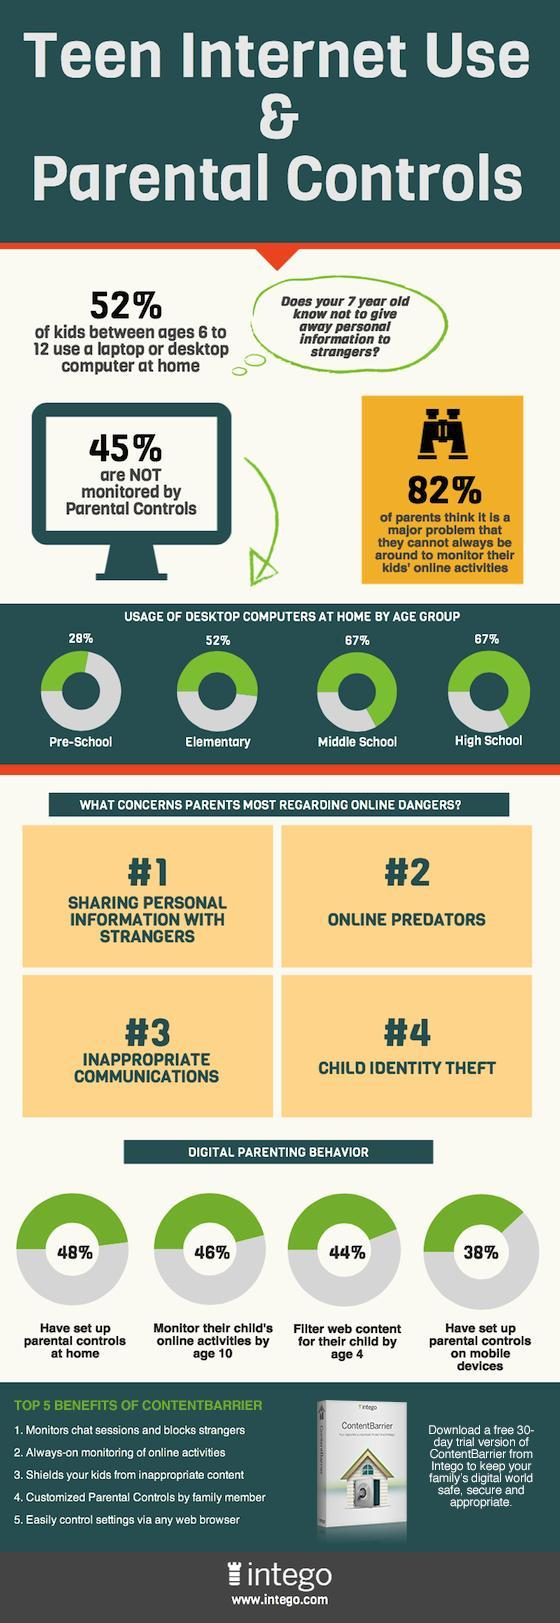What percent of high school students use desktop computers at home?
Answer the question with a short phrase. 67% What matter is of second highest concern for parents regarding children's online safety? online predators what percent of kids using computers at home are of elementary school age? 52% How  many of the parents have set up parental control on mobile devices? 38% How many of the parents have setup parental controls at home? 48% What percent of kids using computers at home are not supervised by parental controls? 45% What percent of pre-school kids use computers at home? 28% How many of the parents are concerned that they can't always monitor their kid's online activities? 82% What is the topmost concern that parents have about their kids' online safety? sharing personal information with strangers How many of the parents filter web content for their child by age 4? 44% 